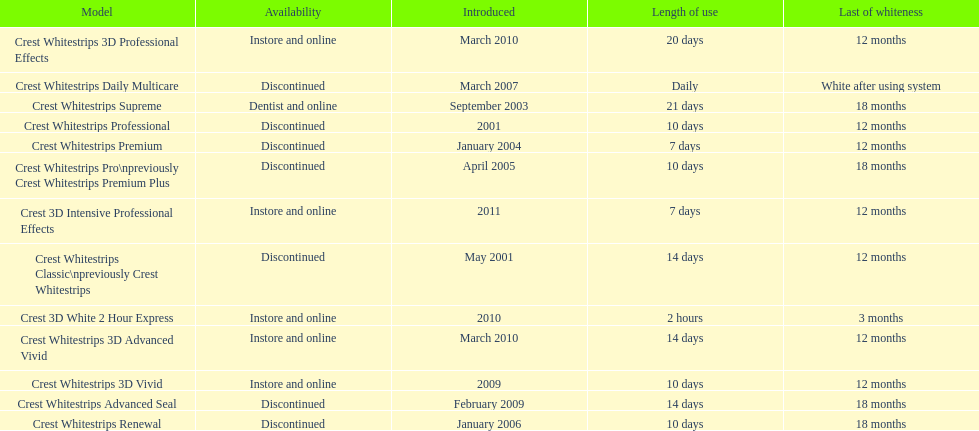Which discontinued product was introduced the same year as crest whitestrips 3d vivid? Crest Whitestrips Advanced Seal. 